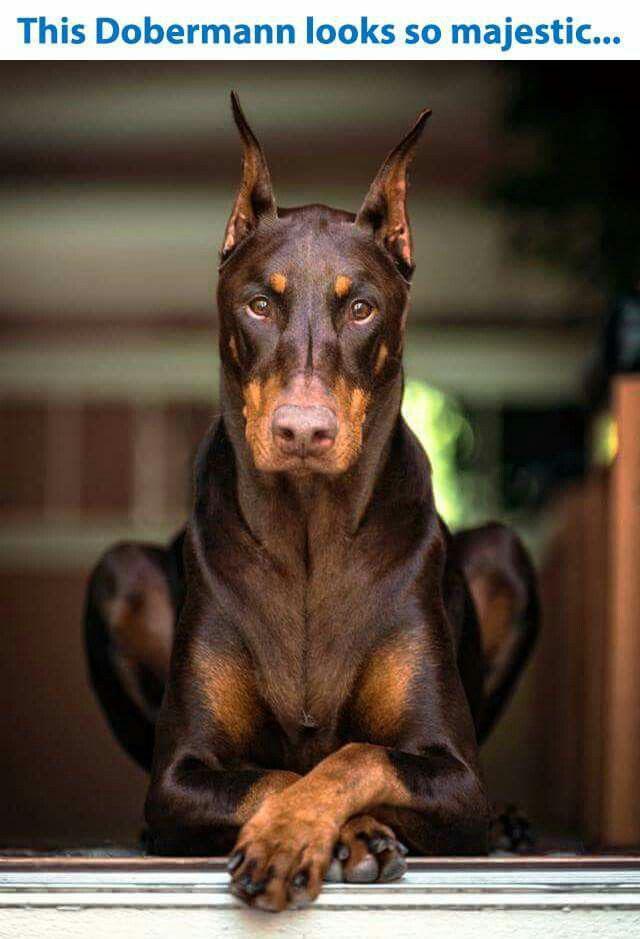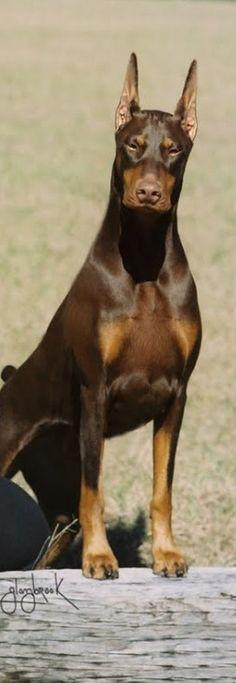The first image is the image on the left, the second image is the image on the right. For the images displayed, is the sentence "there are two dogs on the grass, one of the dogs is laying down" factually correct? Answer yes or no. No. The first image is the image on the left, the second image is the image on the right. Evaluate the accuracy of this statement regarding the images: "There are three dogs and one is a puppy.". Is it true? Answer yes or no. No. 